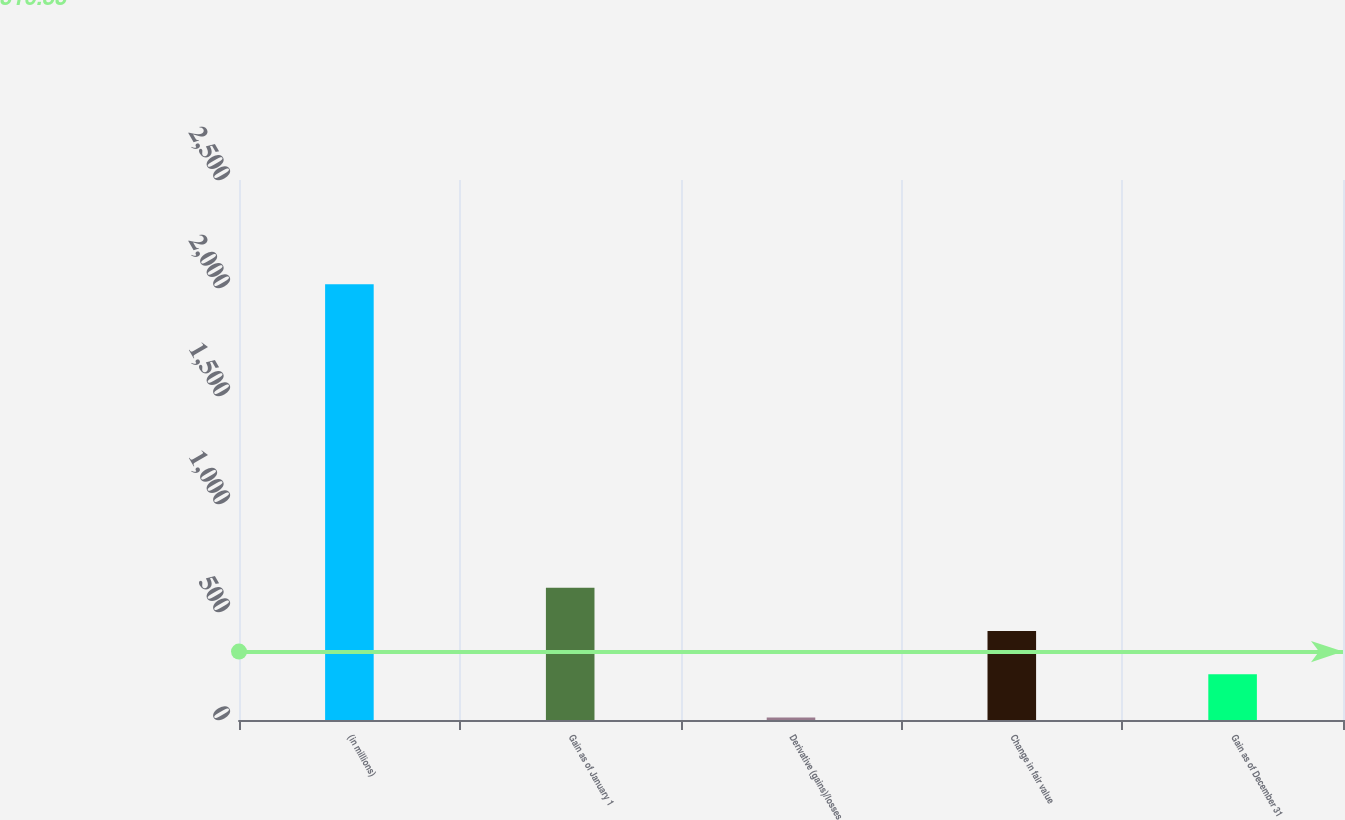Convert chart. <chart><loc_0><loc_0><loc_500><loc_500><bar_chart><fcel>(in millions)<fcel>Gain as of January 1<fcel>Derivative (gains)/losses<fcel>Change in fair value<fcel>Gain as of December 31<nl><fcel>2017<fcel>612.8<fcel>11<fcel>412.2<fcel>211.6<nl></chart> 